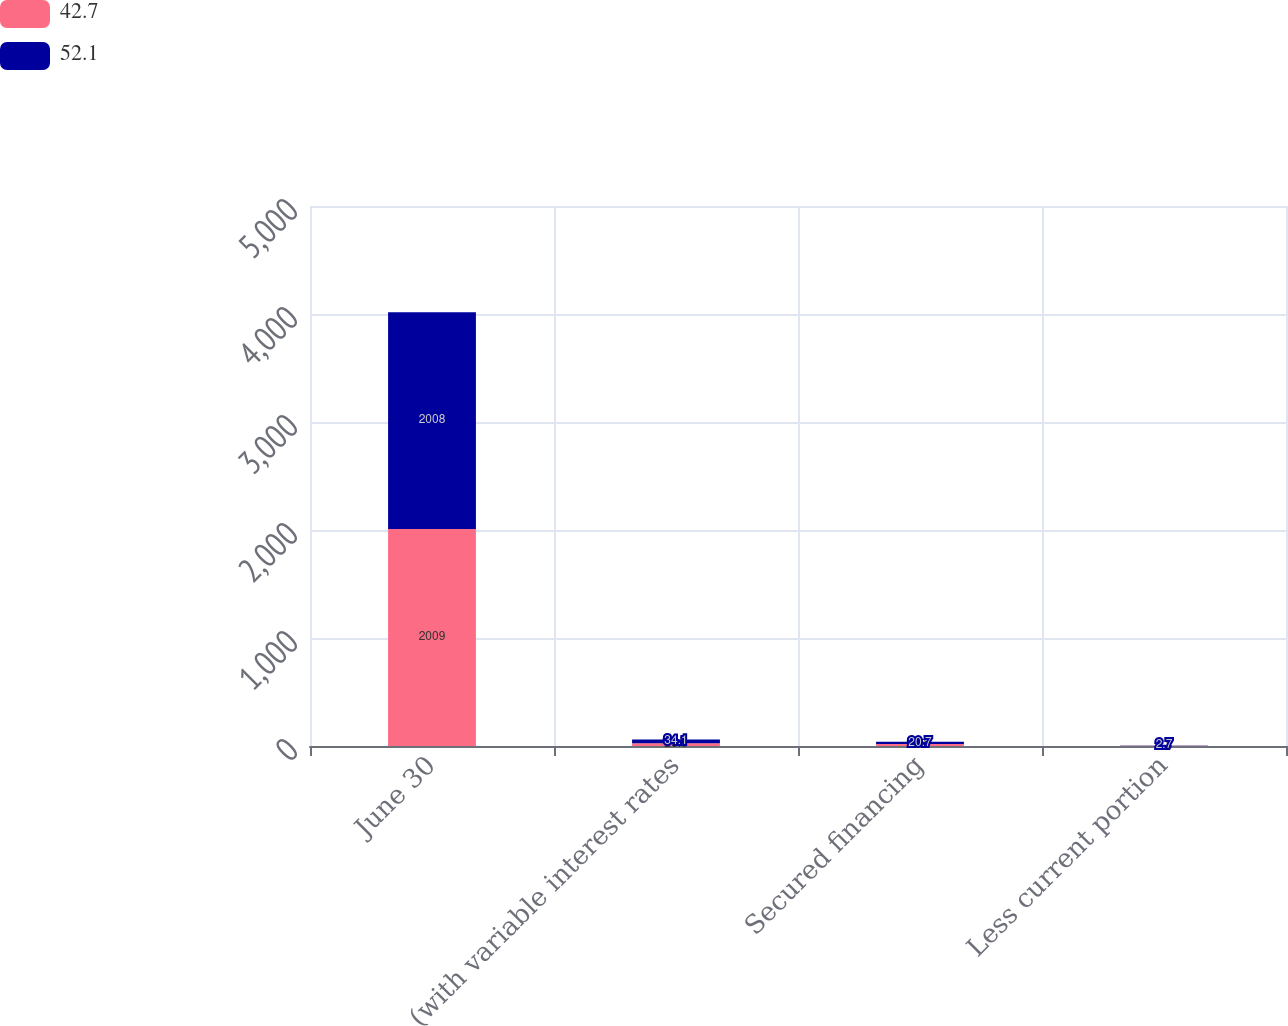Convert chart to OTSL. <chart><loc_0><loc_0><loc_500><loc_500><stacked_bar_chart><ecel><fcel>June 30<fcel>(with variable interest rates<fcel>Secured financing<fcel>Less current portion<nl><fcel>42.7<fcel>2009<fcel>26.5<fcel>19<fcel>2.8<nl><fcel>52.1<fcel>2008<fcel>34.1<fcel>20.7<fcel>2.7<nl></chart> 